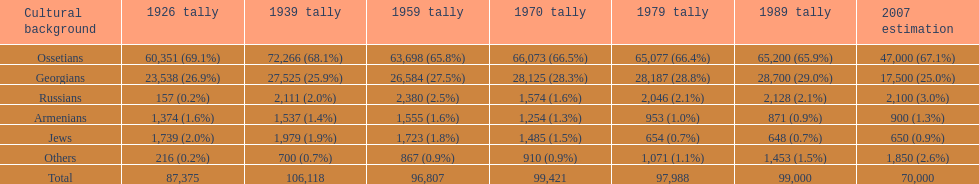In 1926, which demographic had the greatest number of inhabitants? Ossetians. 